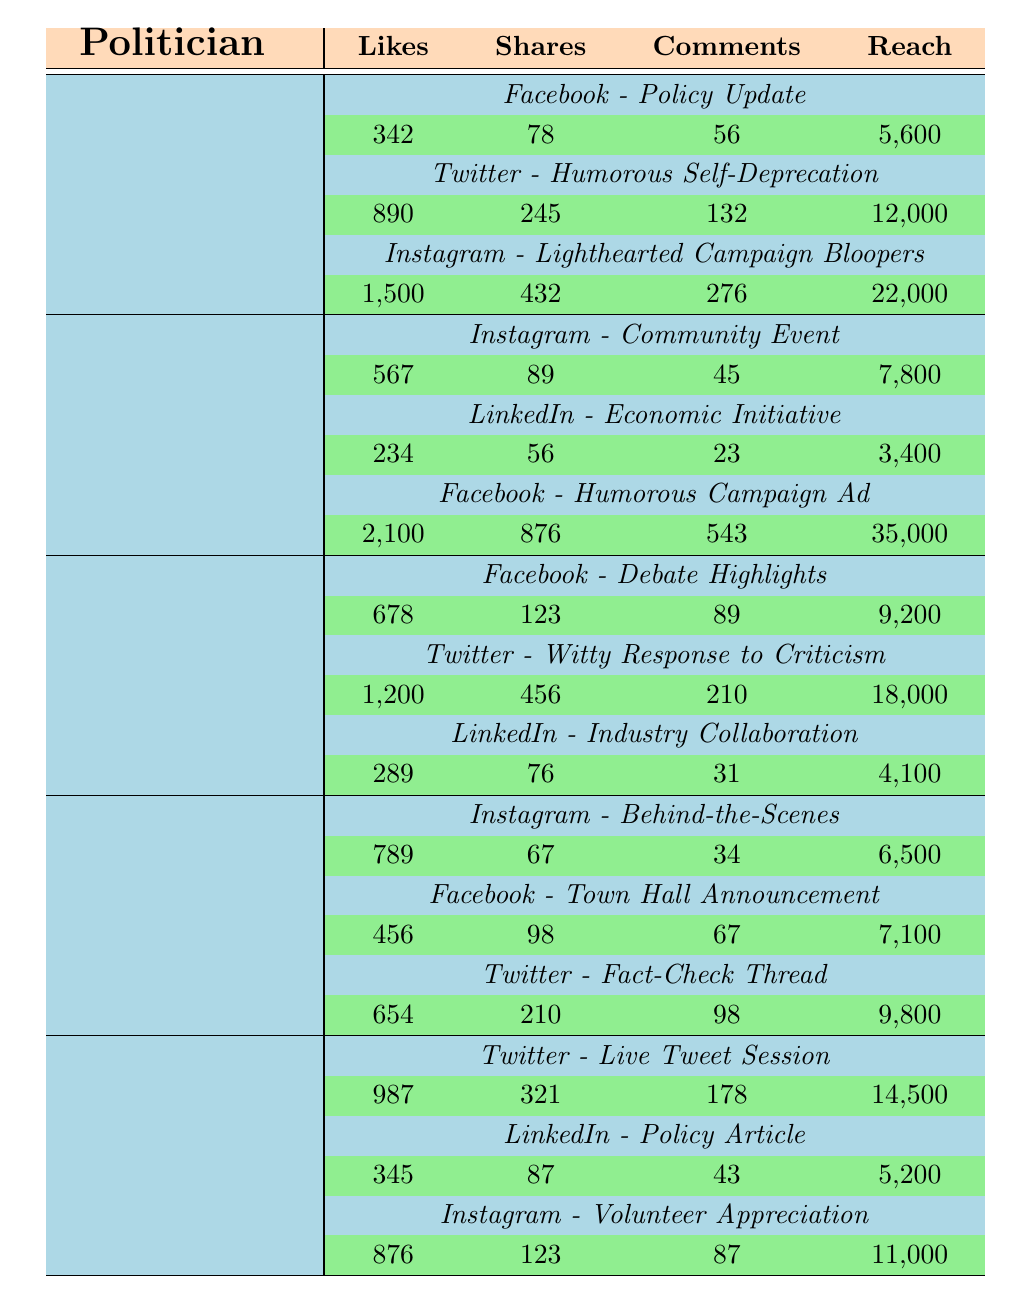What content type did John Doe use for his Instagram post? John Doe's Instagram post is categorized as a "Community Event" based on the data in the table.
Answer: Community Event Which politician had the highest number of likes on a post, and what was the content type? The highest number of likes was 2,100 from John Doe's post labeled "Humorous Campaign Ad" on Facebook.
Answer: John Doe, Humorous Campaign Ad How many comments did Sarah Johnson receive on her Twitter post? According to the table, Sarah Johnson received 210 comments on her Twitter post titled "Witty Response to Criticism."
Answer: 210 What is the average number of shares across all posts by Emily Davis? Emily Davis has three posts with shares totaling 321 + 87 + 123 = 531. Dividing by the number of posts (3), the average is 531/3 = 177.
Answer: 177 Did Jane Smith have more likes on her Instagram post than on her Twitter post? Jane Smith's Instagram post received 1,500 likes, while her Twitter post received 890 likes. Since 1,500 is greater than 890, the statement is true.
Answer: Yes What is the total reach for all posts made by Michael Brown? To find the total reach for Michael Brown, we add his reach values: 6,500 (Instagram) + 7,100 (Facebook) + 9,800 (Twitter) = 23,400.
Answer: 23,400 Which politician had more engagement (likes + shares + comments) on their Facebook posts combined? Jane Smith had (342 likes + 78 shares + 56 comments) = 476 engagement on her Facebook post "Policy Update" and John Doe had (2,100 likes + 876 shares + 543 comments) = 3,519 engagement on "Humorous Campaign Ad." John Doe had more engagement.
Answer: John Doe What was Sarah Johnson's total reach across all platforms? Sarah Johnson's total reach can be calculated by adding: 9,200 (Facebook) + 18,000 (Twitter) + 4,100 (LinkedIn) = 31,300.
Answer: 31,300 